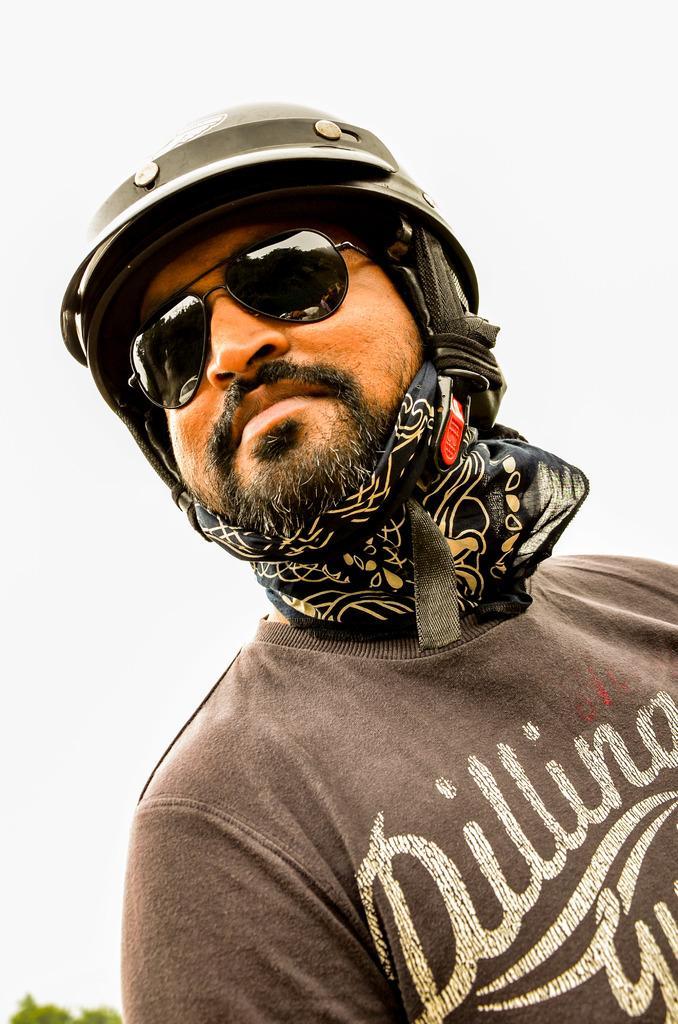How would you summarize this image in a sentence or two? In the picture we can see a man with a gray color T-shirt and something written on it and he is with a helmet and a cloth under the beard and black color shades for the eyes and behind him we can see some part of plants and sky. 